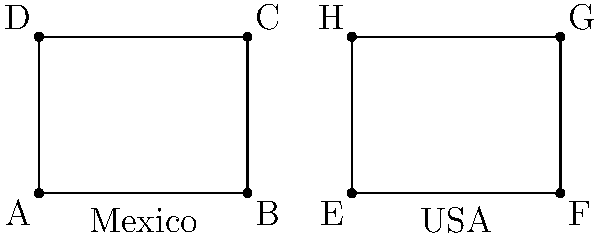The diagram shows two rectangular structures: one representing a low-income housing unit in Mexico and another in the USA. If the rectangles ABCD and EFGH are congruent, which of the following statements must be true?

1) $\overline{AB} \cong \overline{EF}$
2) $\overline{BC} \cong \overline{FG}$
3) $\angle BAD \cong \angle EFH$
4) All of the above Let's analyze this step-by-step:

1) First, recall that congruent polygons have all corresponding sides and angles equal.

2) In this case, we're told that rectangles ABCD and EFGH are congruent.

3) For rectangles, congruence means they have the same length and width.

4) Statement 1: $\overline{AB} \cong \overline{EF}$
   This is true because these are corresponding sides of congruent rectangles.

5) Statement 2: $\overline{BC} \cong \overline{FG}$
   This is also true for the same reason as statement 1.

6) Statement 3: $\angle BAD \cong \angle EFH$
   This is true because all angles in a rectangle are right angles (90°), and corresponding angles of congruent polygons are congruent.

7) Since all three statements are true, the correct answer is "All of the above".

This comparison illustrates that despite being in different countries, low-income housing units can have similar basic geometric structures, reflecting common architectural principles for efficient space usage.
Answer: All of the above 